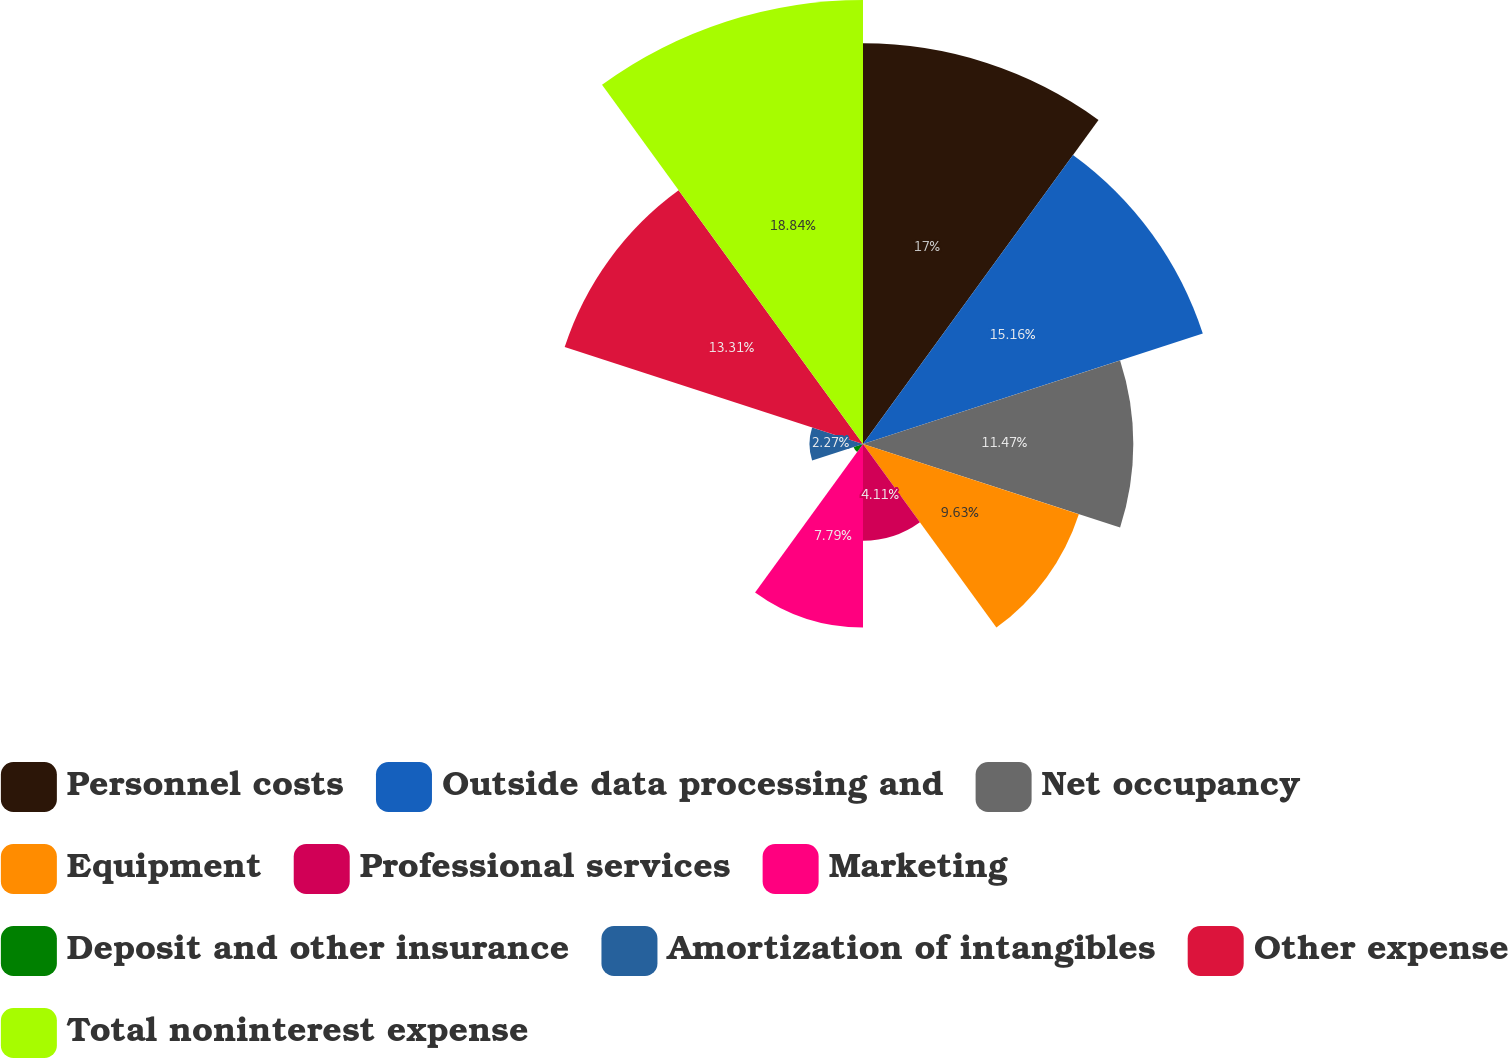Convert chart to OTSL. <chart><loc_0><loc_0><loc_500><loc_500><pie_chart><fcel>Personnel costs<fcel>Outside data processing and<fcel>Net occupancy<fcel>Equipment<fcel>Professional services<fcel>Marketing<fcel>Deposit and other insurance<fcel>Amortization of intangibles<fcel>Other expense<fcel>Total noninterest expense<nl><fcel>17.0%<fcel>15.16%<fcel>11.47%<fcel>9.63%<fcel>4.11%<fcel>7.79%<fcel>0.42%<fcel>2.27%<fcel>13.31%<fcel>18.84%<nl></chart> 